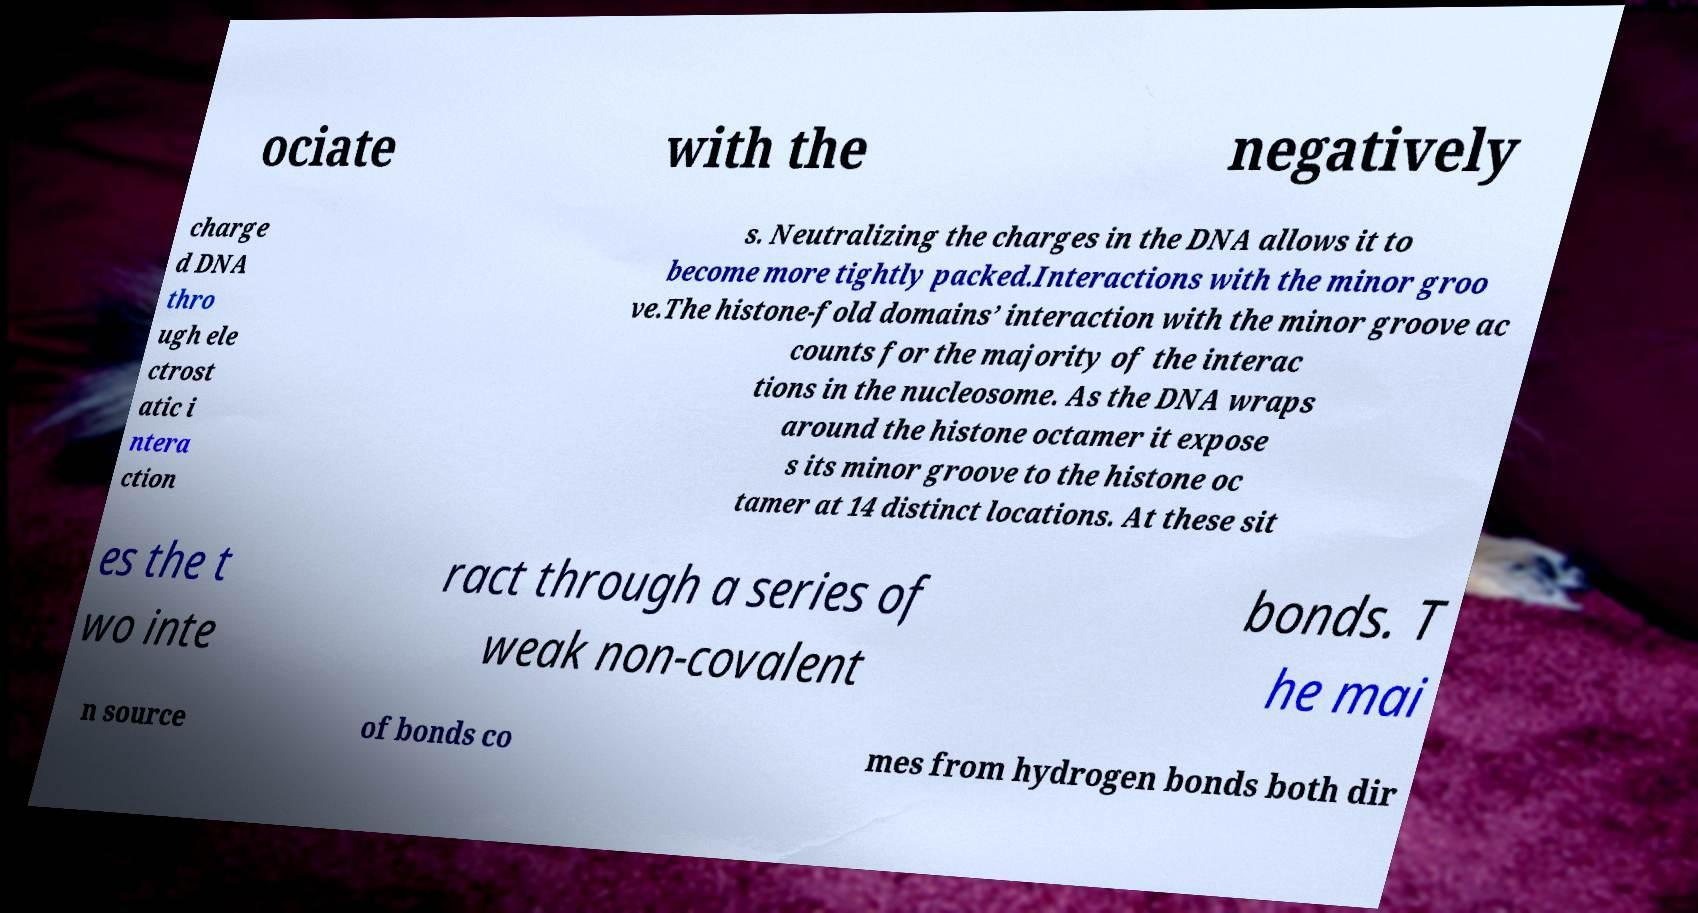There's text embedded in this image that I need extracted. Can you transcribe it verbatim? ociate with the negatively charge d DNA thro ugh ele ctrost atic i ntera ction s. Neutralizing the charges in the DNA allows it to become more tightly packed.Interactions with the minor groo ve.The histone-fold domains’ interaction with the minor groove ac counts for the majority of the interac tions in the nucleosome. As the DNA wraps around the histone octamer it expose s its minor groove to the histone oc tamer at 14 distinct locations. At these sit es the t wo inte ract through a series of weak non-covalent bonds. T he mai n source of bonds co mes from hydrogen bonds both dir 